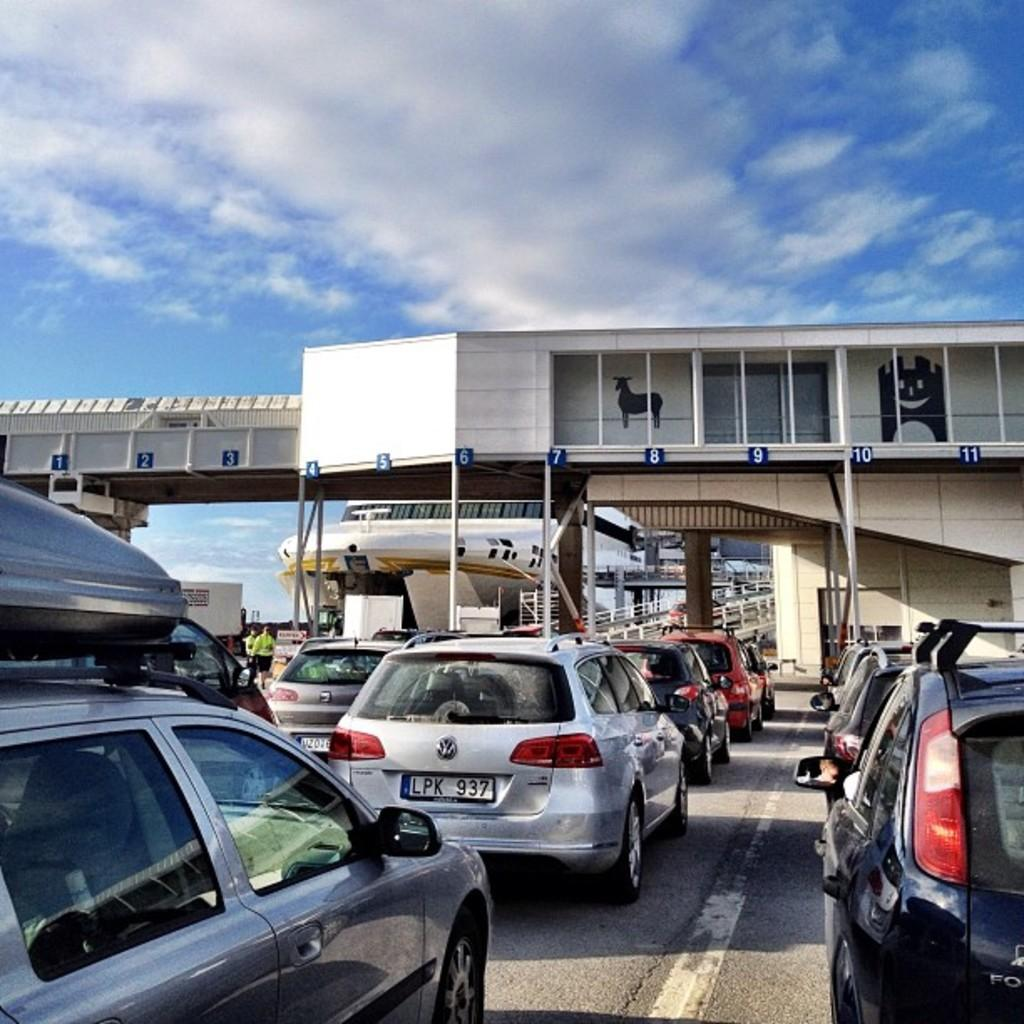What type of vehicles can be seen on the road in the image? There are motor vehicles on the road in the image. What are the people on the road doing? People are standing on the road in the image. What feature can be seen in the image that might be used for safety or support? There are railings in the image. What can be used to identify specific motor vehicles in the image? Number plates are visible on the motor vehicles. What type of structure is present in the image that allows vehicles to cross over a body of water or obstacle? There is a bridge in the image. What is visible in the sky in the image? The sky is visible with clouds in the image. How much did the cup cost in the image? There is no cup present in the image, so it is not possible to determine its cost. What time of day is depicted in the image? The provided facts do not give any information about the time of day, so it cannot be determined from the image. 